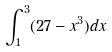<formula> <loc_0><loc_0><loc_500><loc_500>\int _ { 1 } ^ { 3 } ( 2 7 - x ^ { 3 } ) d x</formula> 